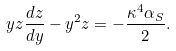<formula> <loc_0><loc_0><loc_500><loc_500>y z \frac { d z } { d y } - y ^ { 2 } z = - \frac { \kappa ^ { 4 } \alpha _ { S } } { 2 } .</formula> 